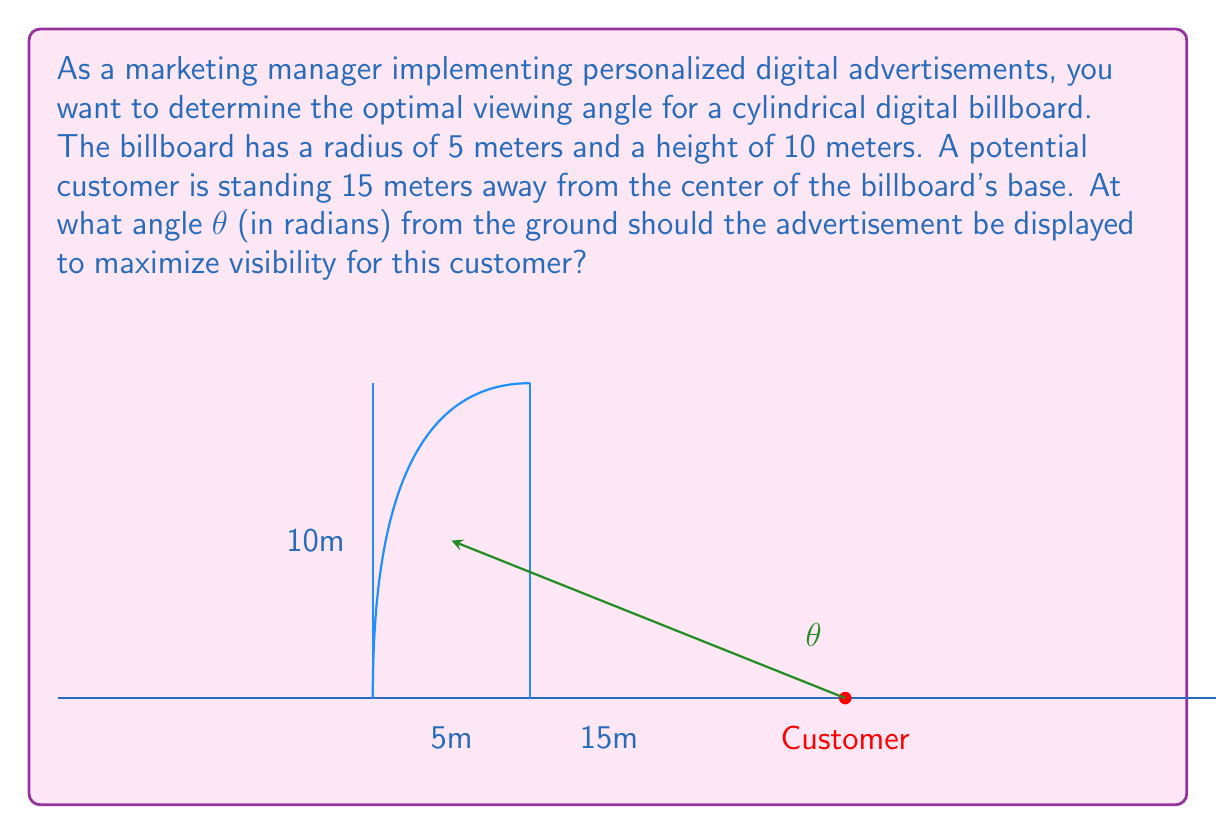Help me with this question. To solve this problem, we'll use polar coordinates and trigonometry. Let's approach this step-by-step:

1) First, we need to find the angle θ that maximizes visibility. This occurs when the line of sight is perpendicular to the surface of the billboard.

2) We can model this situation as a right triangle, where:
   - The hypotenuse is the line from the customer to the point on the billboard
   - One side is the horizontal distance from the customer to the center of the billboard (15m)
   - The other side is the height from the ground to the point on the billboard

3) Let's call the height of the optimal viewing point h. We can express the tangent of θ as:

   $$\tan(\theta) = \frac{h}{15}$$

4) Now, we need to find the relationship between h and the radius of the billboard. If we draw a line from the center of the billboard to the optimal viewing point, it forms a right angle with the line of sight. This gives us another right triangle.

5) In this new triangle, we can express the tangent as:

   $$\tan(\theta) = \frac{5}{10-h}$$

6) Since these two expressions for tan(θ) are equal, we can set up an equation:

   $$\frac{h}{15} = \frac{5}{10-h}$$

7) Cross-multiply:

   $$h(10-h) = 75$$

8) Expand:

   $$10h - h^2 = 75$$

9) Rearrange into standard quadratic form:

   $$h^2 - 10h + 75 = 0$$

10) Solve using the quadratic formula: $h = \frac{-b \pm \sqrt{b^2 - 4ac}}{2a}$

    $$h = \frac{10 \pm \sqrt{100 - 300}}{2} = \frac{10 \pm \sqrt{-200}}{2}$$

11) Since we can't have an imaginary height, we take the positive root:

    $$h = 5 + \frac{\sqrt{200}}{2} \approx 12.07$$

12) Now that we have h, we can find θ:

    $$\theta = \arctan(\frac{h}{15}) = \arctan(\frac{12.07}{15}) \approx 0.6779$$

Therefore, the optimal viewing angle is approximately 0.6779 radians.
Answer: $\theta \approx 0.6779$ radians 